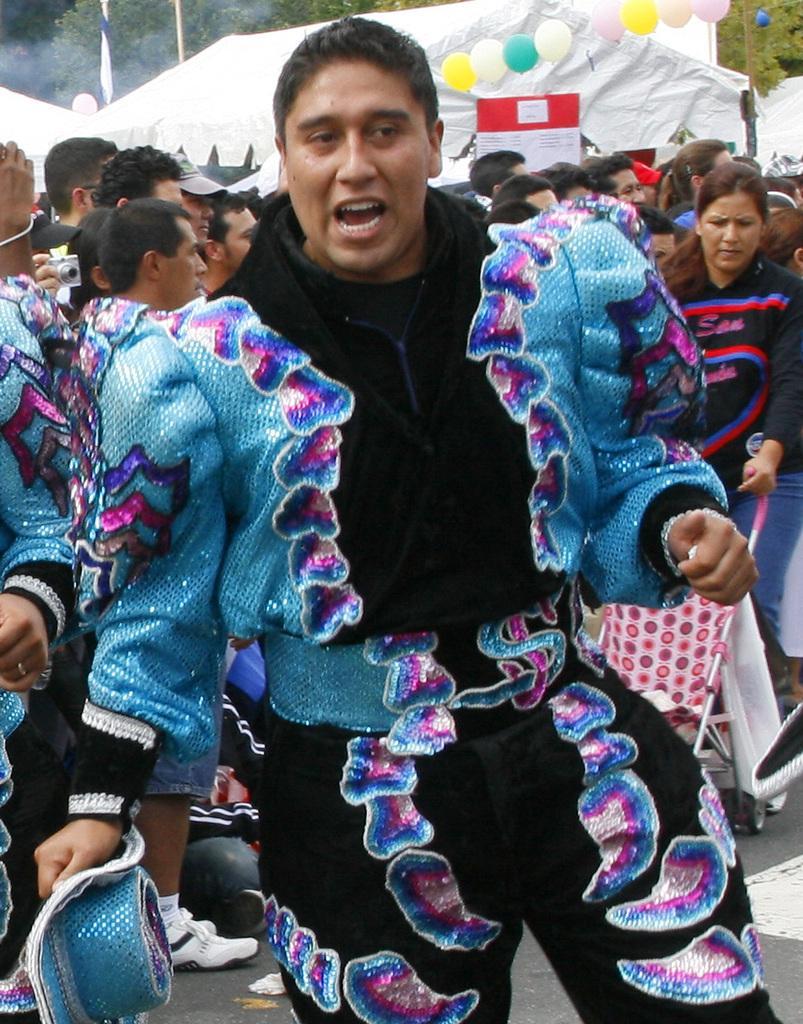How would you summarize this image in a sentence or two? In this image, I can see a man standing with a fancy dress. Behind the man, there are group of people standing. In the background, I can see a ten, board, balloons and trees. 